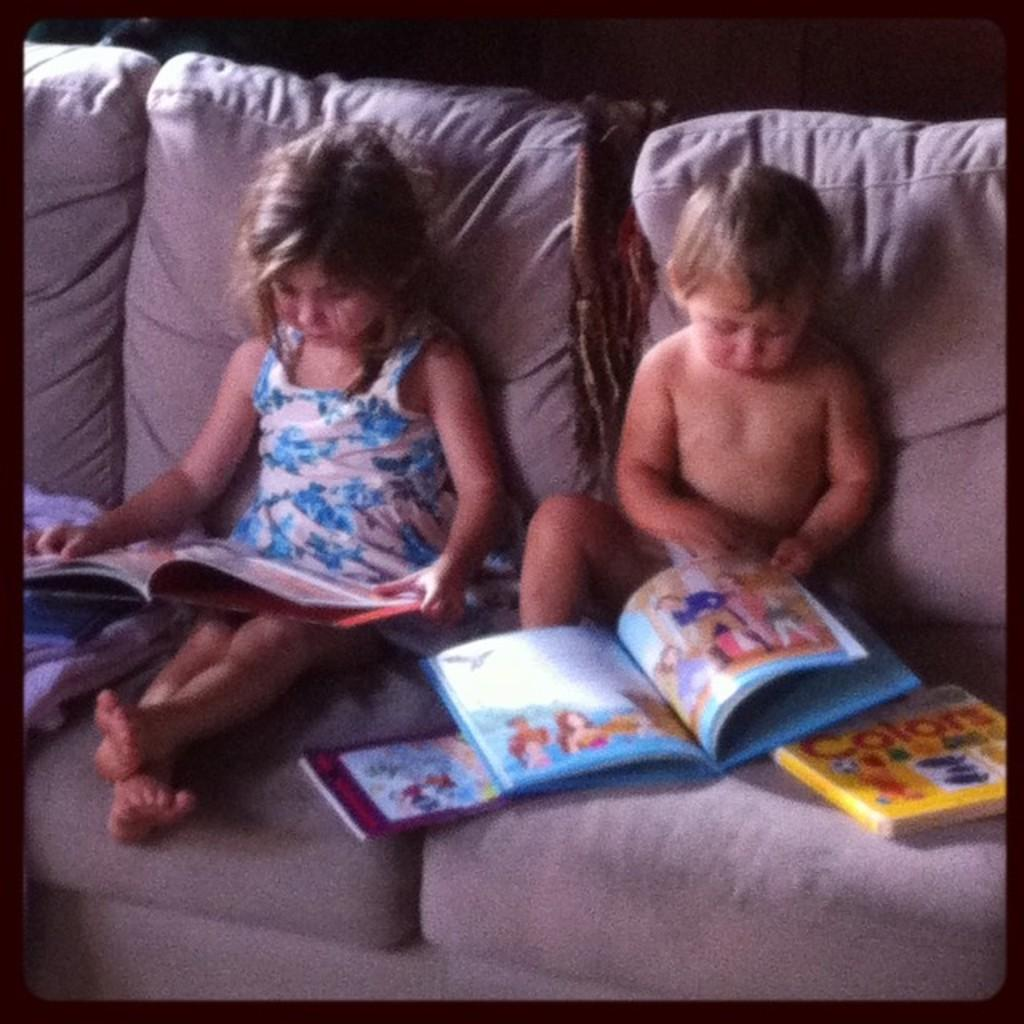Who is present in the image? There are kids in the image. What are the kids doing in the image? The kids are sitting on a sofa and holding books. What else can be seen on the sofa? There are books on the sofa and a blanket. What type of fact can be seen wearing a hat in the image? There is no fact or apparel present in the image; it features kids sitting on a sofa and holding books. 